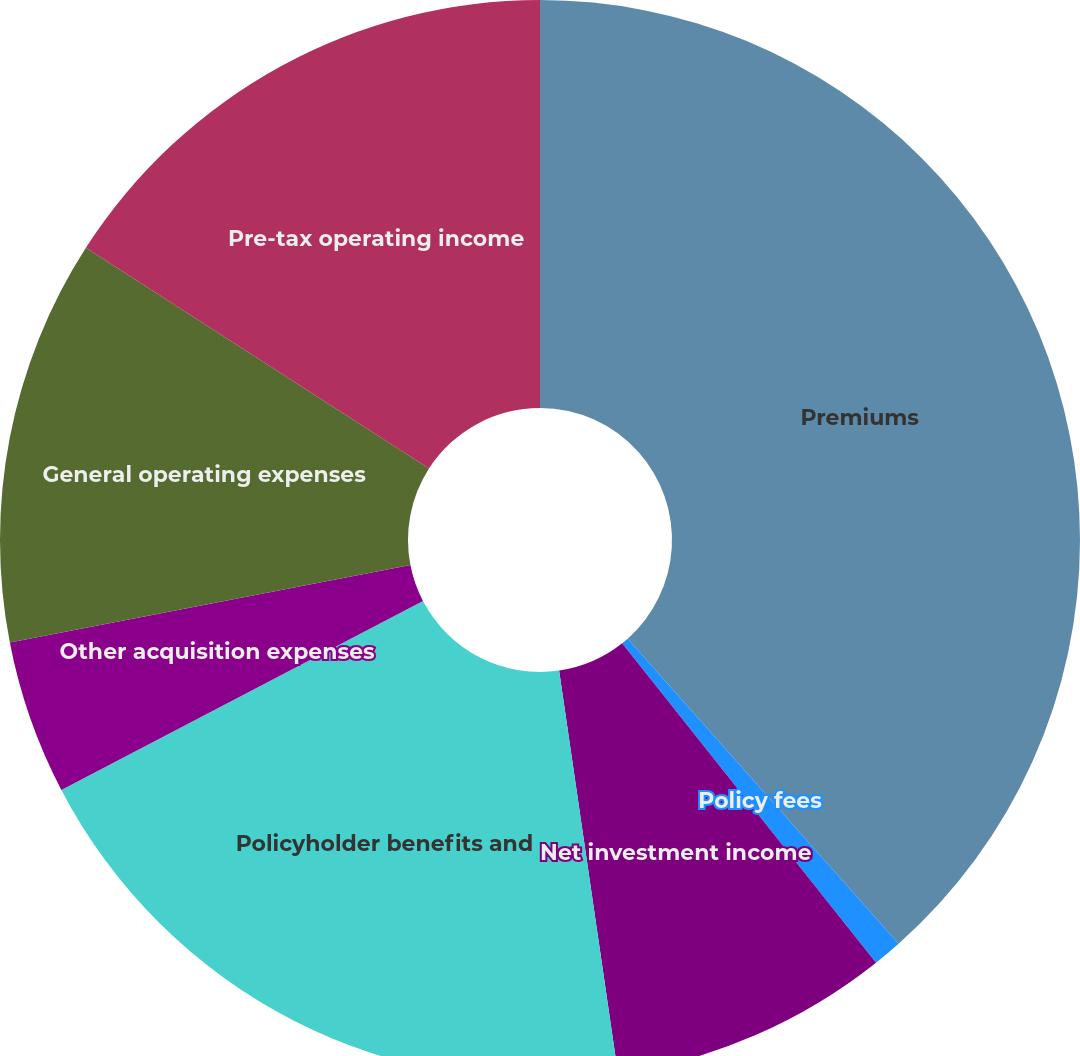Convert chart. <chart><loc_0><loc_0><loc_500><loc_500><pie_chart><fcel>Premiums<fcel>Policy fees<fcel>Net investment income<fcel>Policyholder benefits and<fcel>Other acquisition expenses<fcel>General operating expenses<fcel>Pre-tax operating income<nl><fcel>38.44%<fcel>0.87%<fcel>8.38%<fcel>19.65%<fcel>4.62%<fcel>12.14%<fcel>15.9%<nl></chart> 